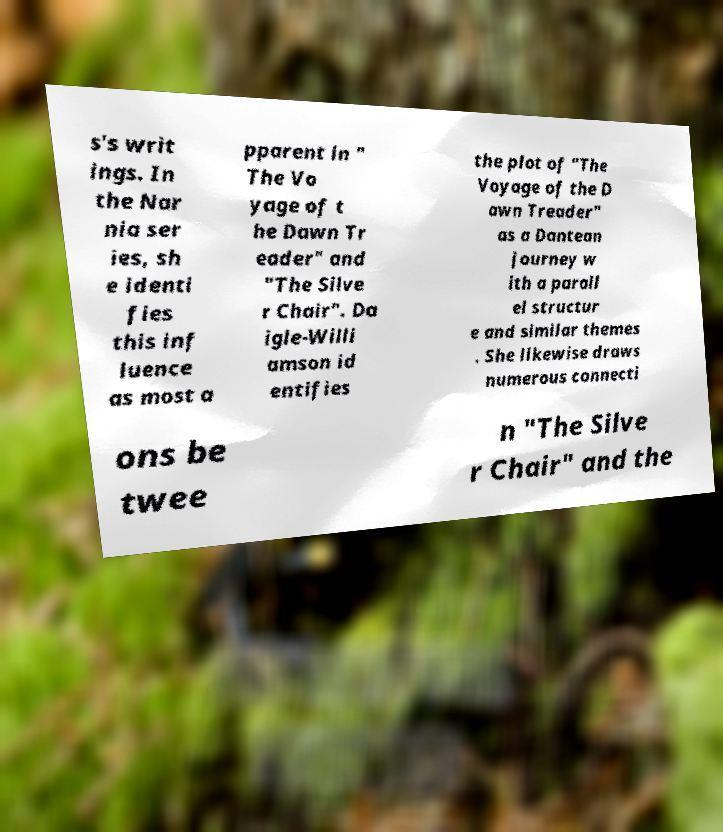Could you extract and type out the text from this image? s's writ ings. In the Nar nia ser ies, sh e identi fies this inf luence as most a pparent in " The Vo yage of t he Dawn Tr eader" and "The Silve r Chair". Da igle-Willi amson id entifies the plot of "The Voyage of the D awn Treader" as a Dantean journey w ith a parall el structur e and similar themes . She likewise draws numerous connecti ons be twee n "The Silve r Chair" and the 